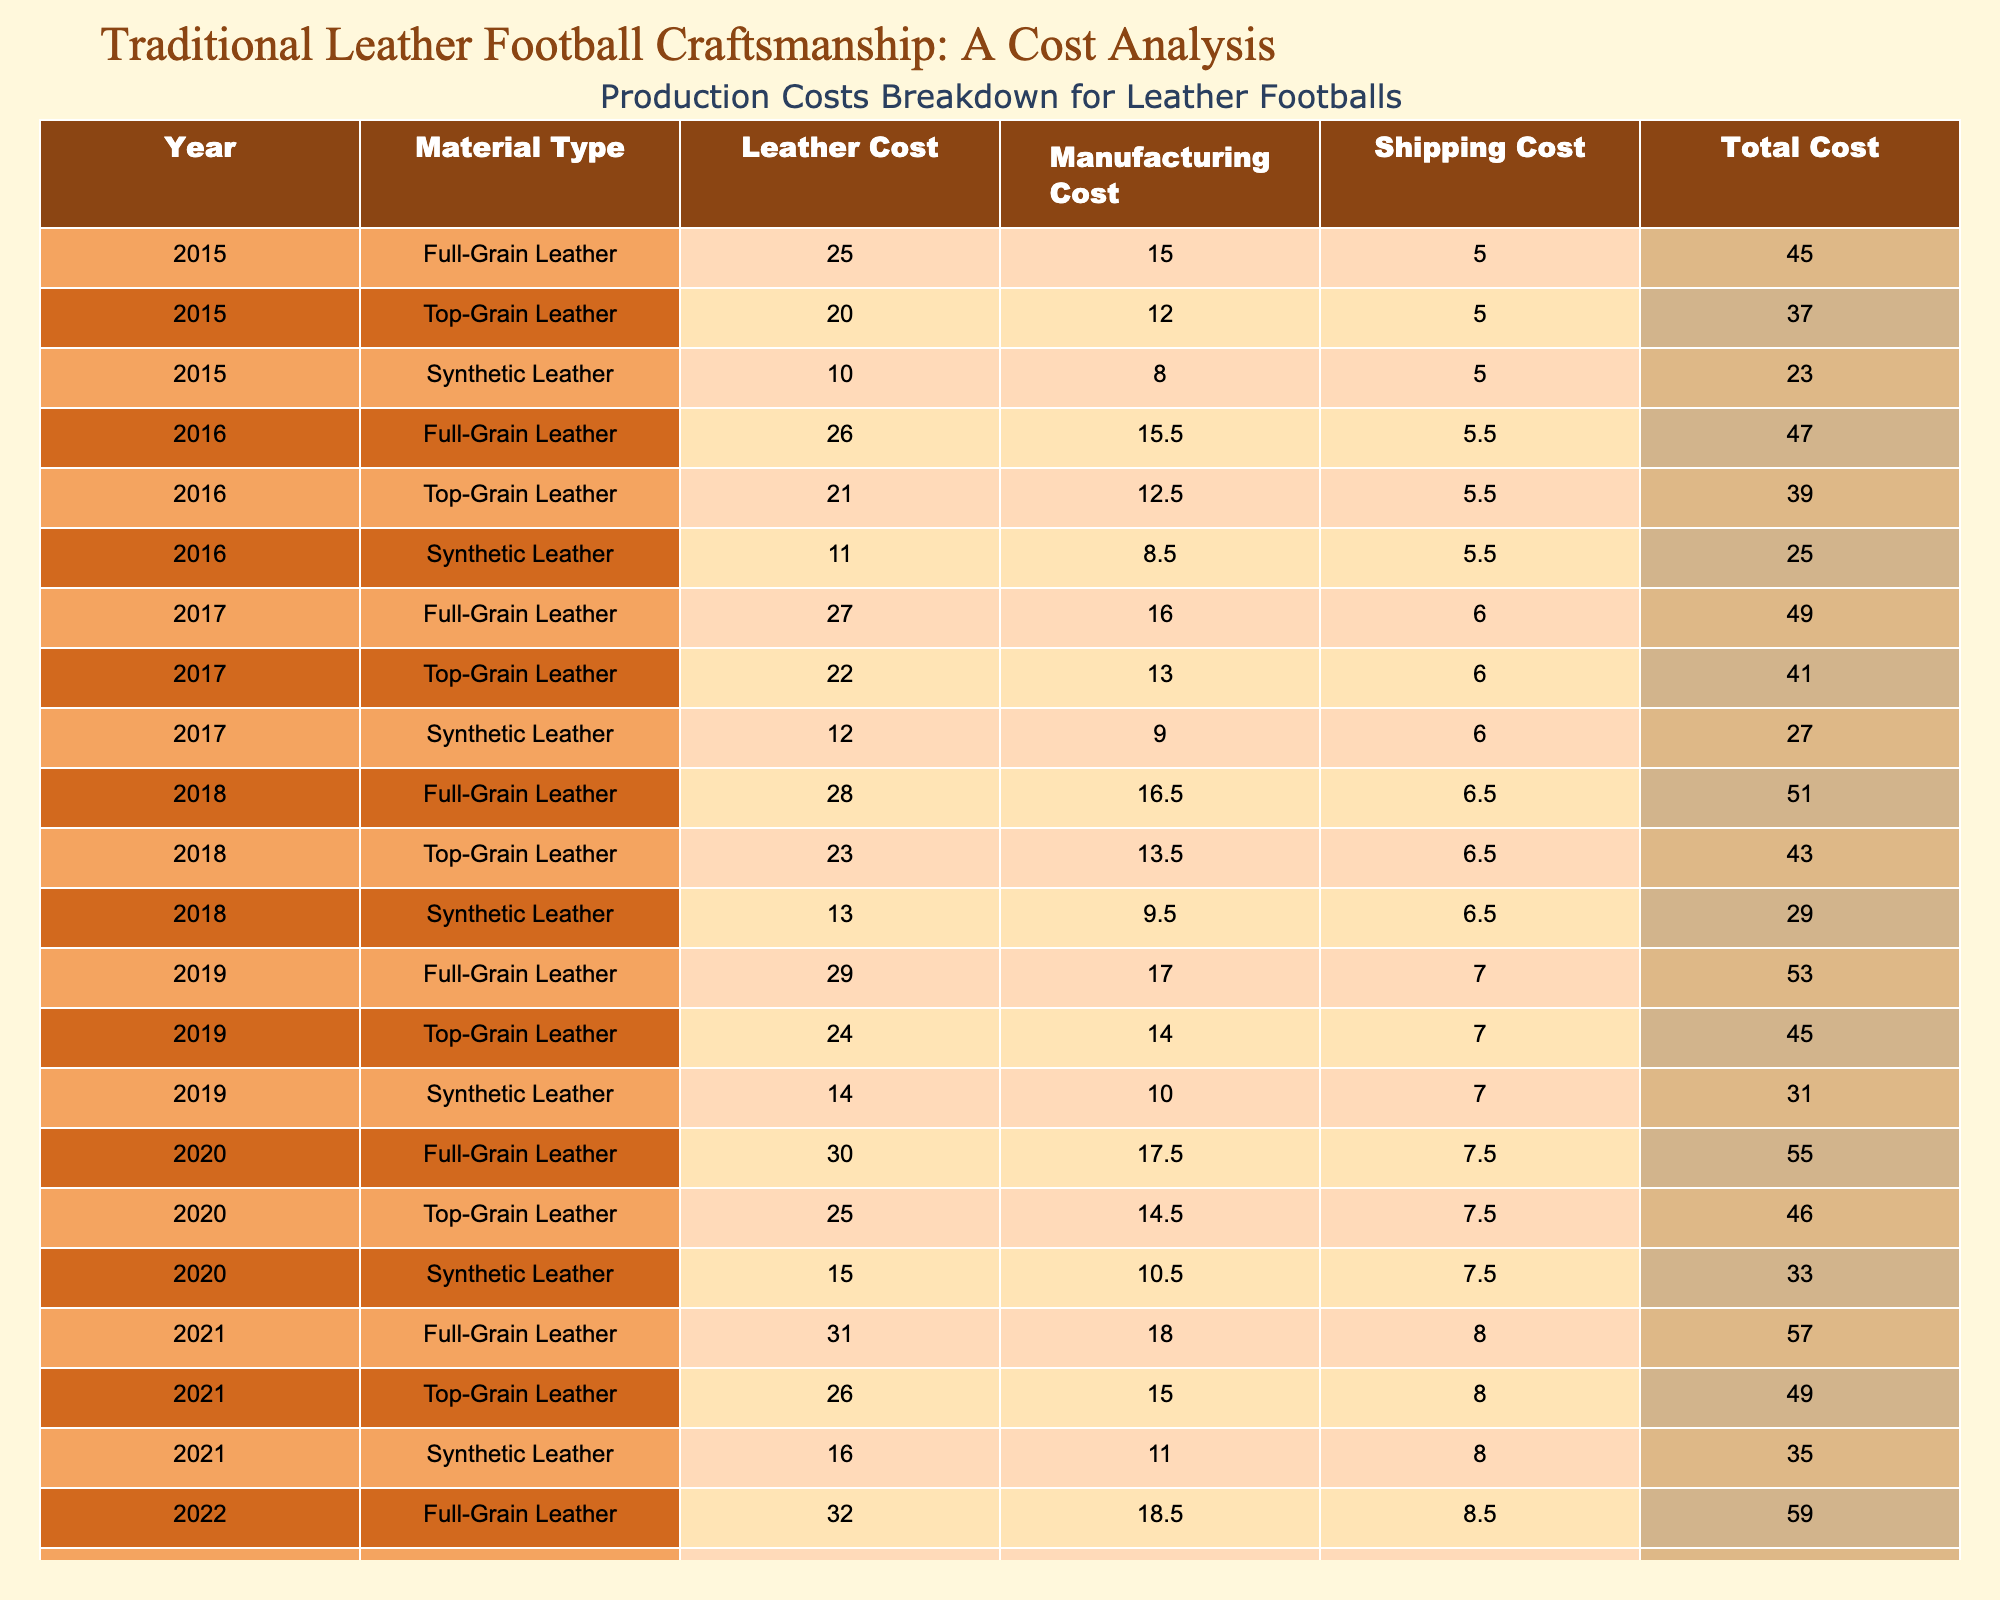What was the total cost of producing a Full-Grain Leather football in 2019? Referring to the table, the total cost for a Full-Grain Leather football in 2019 is listed under the "Total Cost" column as 53.00.
Answer: 53.00 How much more does a Full-Grain Leather football cost compared to a Synthetic Leather football in 2021? In 2021, the cost of a Full-Grain Leather football is 57.00, and the cost of a Synthetic Leather football is 35.00. The difference is 57.00 - 35.00 = 22.00.
Answer: 22.00 Is the manufacturing cost of a Top-Grain Leather football higher in 2022 than in 2020? The manufacturing cost for Top-Grain Leather footballs in 2022 is 15.50, while in 2020 it is 14.50. Since 15.50 is greater than 14.50, the statement is true.
Answer: Yes What is the average total cost of producing a Synthetic Leather football from 2015 to 2023? The total costs for Synthetic Leather footballs from 2015 to 2023 are: 23.00, 25.00, 27.00, 29.00, 31.00, 33.00, 39.00. Summing these values gives: 23.00 + 25.00 + 27.00 + 29.00 + 31.00 + 33.00 + 39.00 =  207.00. Dividing by the 7 years gives the average total cost as 207.00 / 7 ≈ 29.57.
Answer: 29.57 What was the highest shipping cost for any type of football in 2023? In 2023, the shipping costs for all types of footballs are: Full-Grain 9.00, Top-Grain 9.00, and Synthetic 9.00. The highest shipping cost among them is 9.00.
Answer: 9.00 Which material type experienced the largest increase in manufacturing costs from 2015 to 2023? The manufacturing costs are: Full-Grain Leather (15.00 to 19.00) increases by 4.00, Top-Grain Leather (12.00 to 16.00) increases by 4.00, and Synthetic Leather (8.00 to 12.00) increases by 4.00. All types had the same increase.
Answer: All types had an increase of 4.00 Calculate the total cost of producing Top-Grain Leather footballs over the years 2017 to 2020. The total costs for Top-Grain Leather from 2017 to 2020 are: 41.00 (2017) + 45.00 (2018) + 46.00 (2019) + 49.00 (2020). Summing these values gives: 41.00 + 45.00 + 46.00 + 49.00 = 181.00.
Answer: 181.00 Did the cost of Full-Grain Leather footballs increase every year from 2015 to 2023? Checking the costs: 25.00 (2015), 26.00 (2016), 27.00 (2017), 28.00 (2018), 29.00 (2019), 30.00 (2020), 31.00 (2021), 32.00 (2022), 33.00 (2023) shows that there is a consistent increase each year. Therefore, the answer is true.
Answer: Yes What is the total manufacturing cost for all types of leather footballs in 2022? The manufacturing costs for 2022 are: Full-Grain 18.50, Top-Grain 15.50, Synthetic 11.50. Summing these values gives: 18.50 + 15.50 + 11.50 = 45.50.
Answer: 45.50 How has the leather cost of Full-Grain Leather footballs changed from 2015 to 2023? The leather cost in 2015 was 25.00 and in 2023 it is 33.00. The increase is calculated as 33.00 - 25.00 = 8.00 over the 8 years.
Answer: Increased by 8.00 